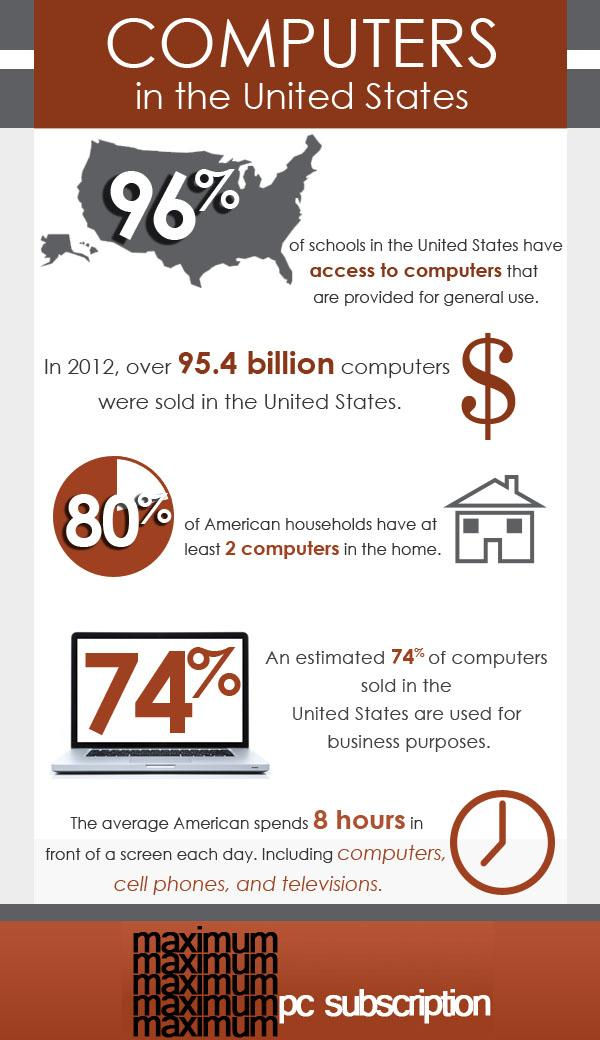Mention a couple of crucial points in this snapshot. According to estimates, approximately 74% of computers sold in the United States are for business purposes. According to recent data, only 4% of schools in the United States lack access to computers. 